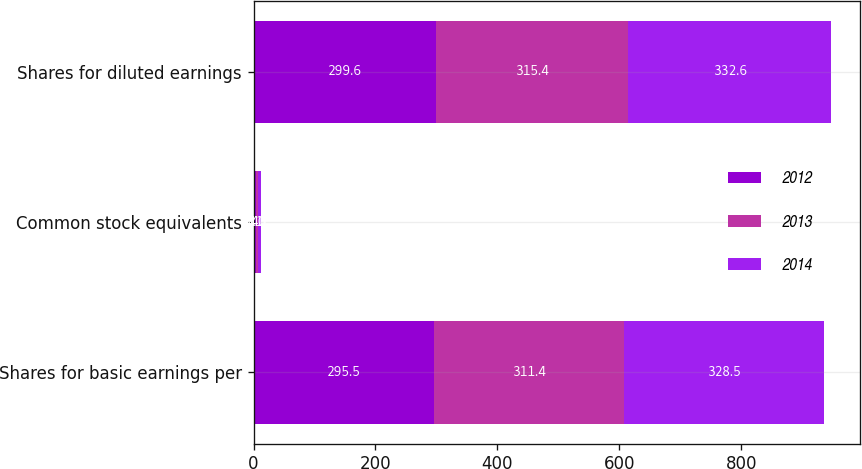<chart> <loc_0><loc_0><loc_500><loc_500><stacked_bar_chart><ecel><fcel>Shares for basic earnings per<fcel>Common stock equivalents<fcel>Shares for diluted earnings<nl><fcel>2012<fcel>295.5<fcel>4.1<fcel>299.6<nl><fcel>2013<fcel>311.4<fcel>4<fcel>315.4<nl><fcel>2014<fcel>328.5<fcel>4.1<fcel>332.6<nl></chart> 